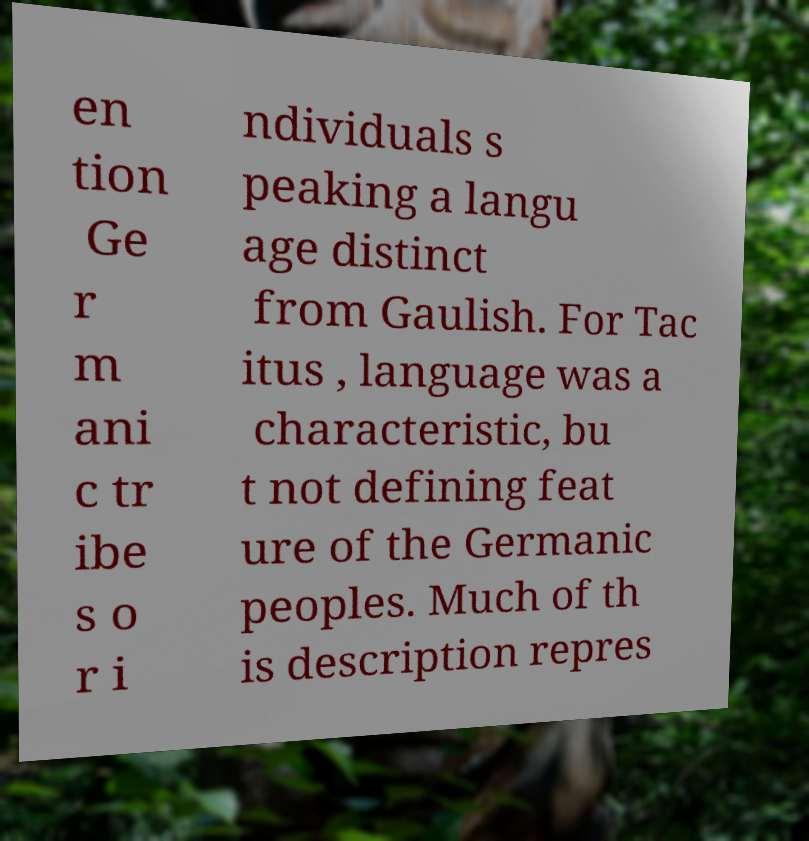Could you assist in decoding the text presented in this image and type it out clearly? en tion Ge r m ani c tr ibe s o r i ndividuals s peaking a langu age distinct from Gaulish. For Tac itus , language was a characteristic, bu t not defining feat ure of the Germanic peoples. Much of th is description repres 